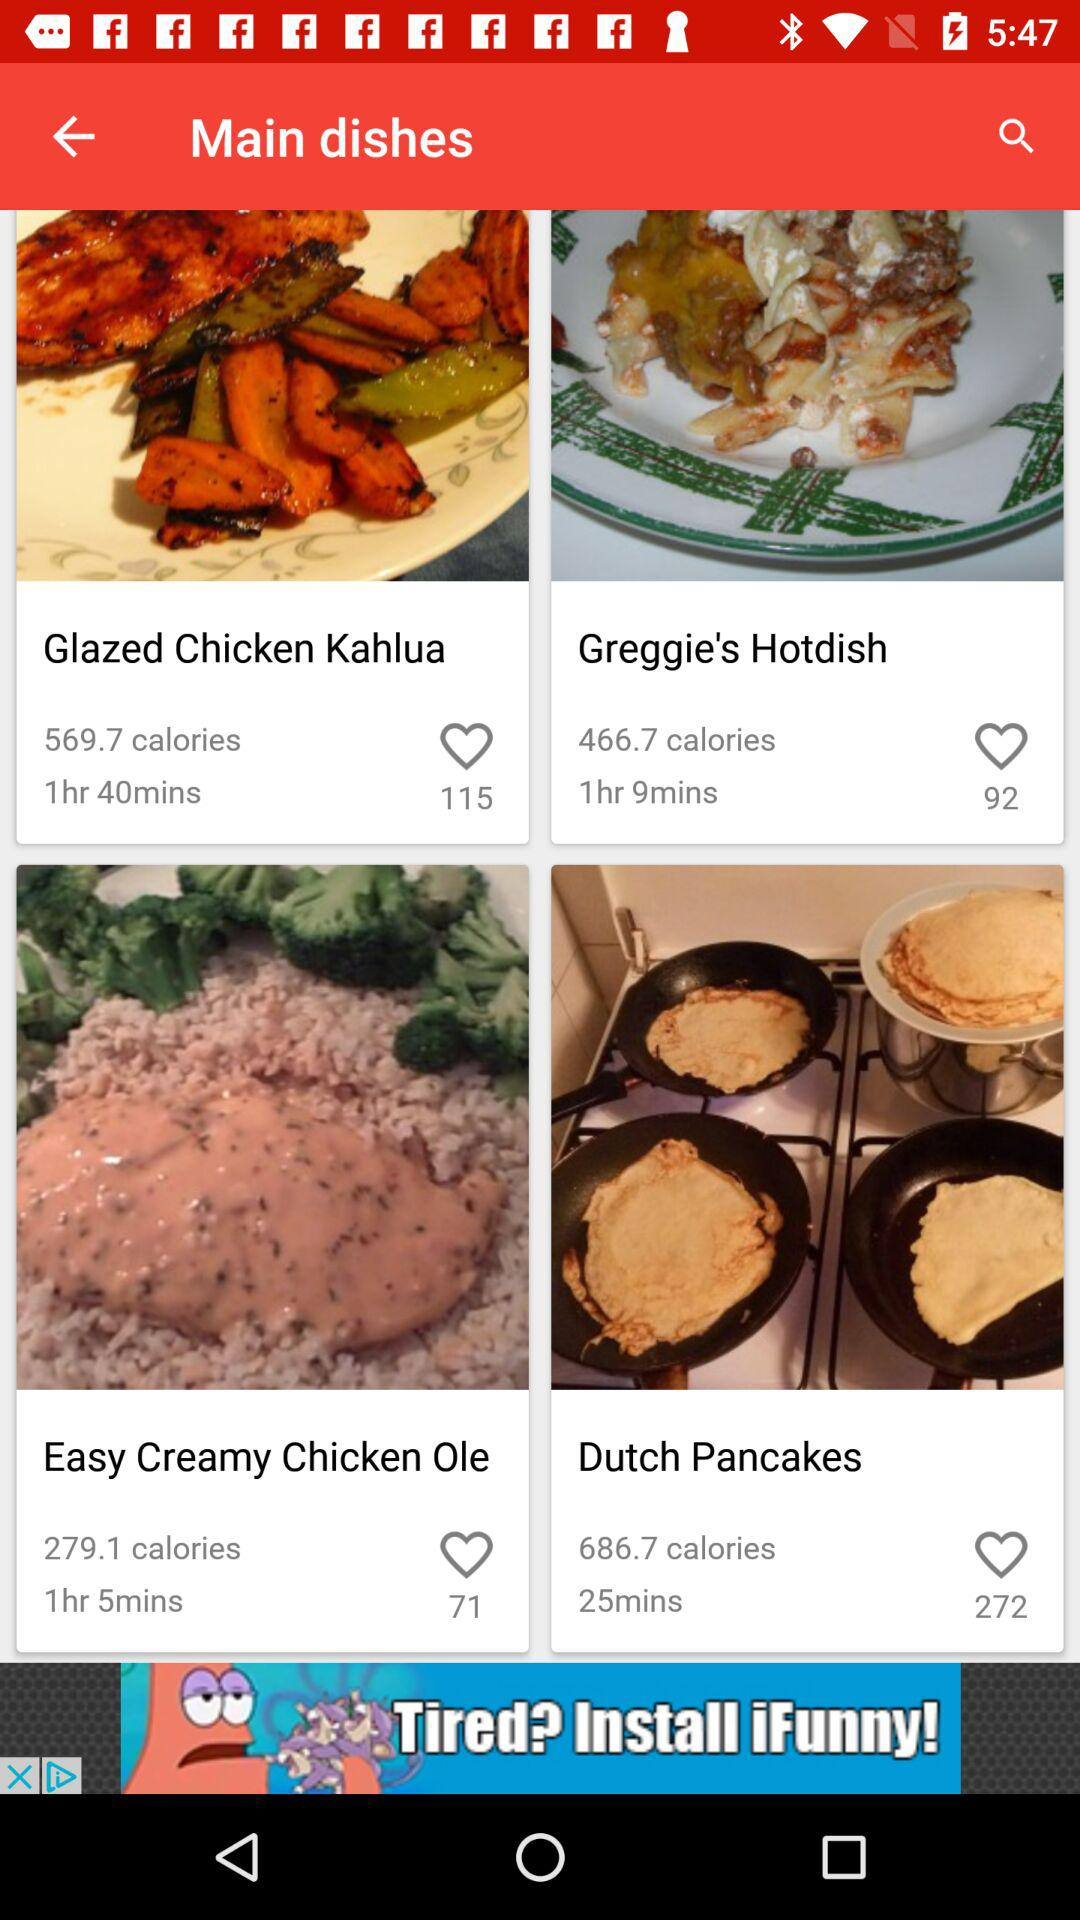What is the calorie count of "Easy Creamy Chicken Ole"? The calorie count of "Easy Creamy Chicken Ole" is 279.1. 